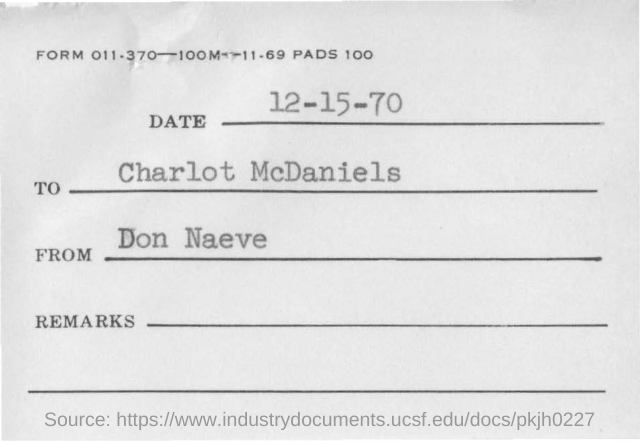What is written in top of the document ?
Give a very brief answer. FORM 011.370-100M-11.69 PADS 100. What is date mentioned in the document ?
Give a very brief answer. 12-15-70. Who sent this ?
Offer a very short reply. DON NAEVE. Who is the recipient ?
Make the answer very short. Charlot McDaniels. 